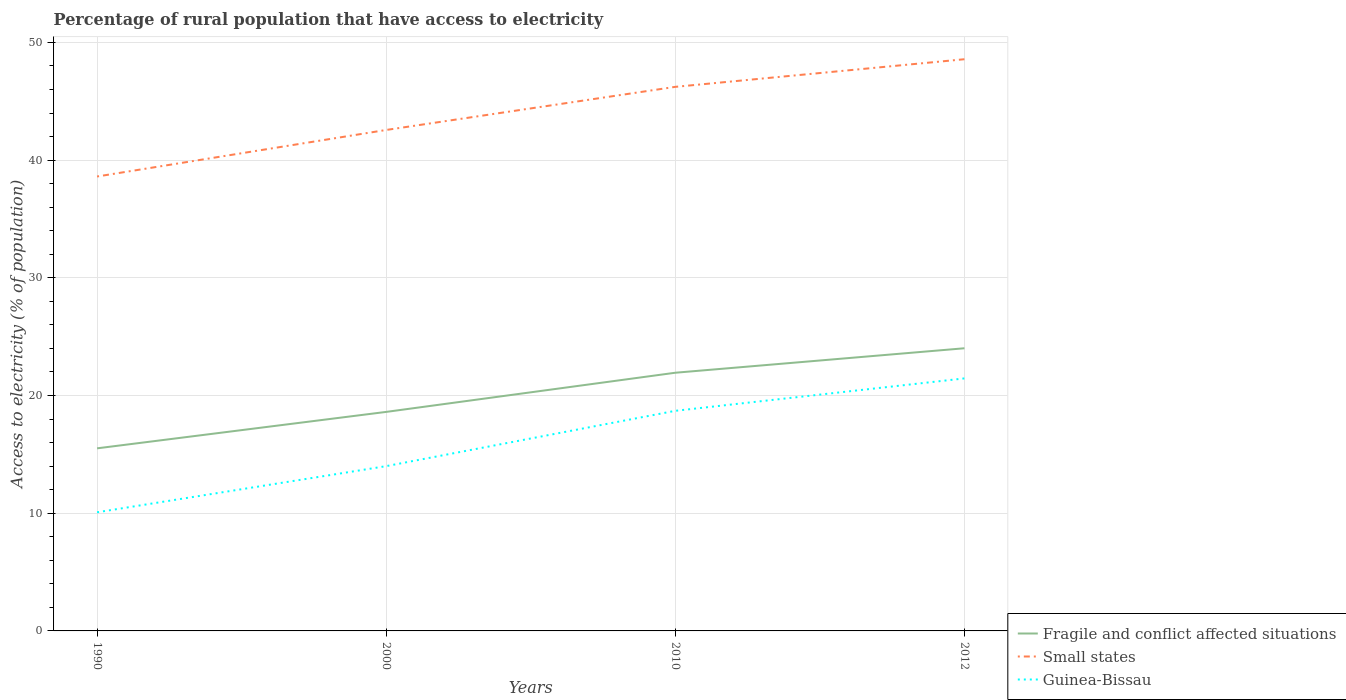How many different coloured lines are there?
Give a very brief answer. 3. Does the line corresponding to Fragile and conflict affected situations intersect with the line corresponding to Small states?
Offer a very short reply. No. Across all years, what is the maximum percentage of rural population that have access to electricity in Fragile and conflict affected situations?
Offer a very short reply. 15.51. In which year was the percentage of rural population that have access to electricity in Guinea-Bissau maximum?
Your response must be concise. 1990. What is the total percentage of rural population that have access to electricity in Small states in the graph?
Your response must be concise. -3.66. What is the difference between the highest and the second highest percentage of rural population that have access to electricity in Fragile and conflict affected situations?
Your response must be concise. 8.5. What is the difference between the highest and the lowest percentage of rural population that have access to electricity in Fragile and conflict affected situations?
Your answer should be compact. 2. How many years are there in the graph?
Ensure brevity in your answer.  4. What is the difference between two consecutive major ticks on the Y-axis?
Your answer should be compact. 10. Does the graph contain grids?
Your answer should be very brief. Yes. Where does the legend appear in the graph?
Provide a succinct answer. Bottom right. How many legend labels are there?
Offer a very short reply. 3. How are the legend labels stacked?
Provide a succinct answer. Vertical. What is the title of the graph?
Keep it short and to the point. Percentage of rural population that have access to electricity. What is the label or title of the X-axis?
Provide a succinct answer. Years. What is the label or title of the Y-axis?
Provide a succinct answer. Access to electricity (% of population). What is the Access to electricity (% of population) of Fragile and conflict affected situations in 1990?
Provide a succinct answer. 15.51. What is the Access to electricity (% of population) in Small states in 1990?
Offer a terse response. 38.61. What is the Access to electricity (% of population) in Guinea-Bissau in 1990?
Your answer should be very brief. 10.08. What is the Access to electricity (% of population) of Fragile and conflict affected situations in 2000?
Offer a terse response. 18.61. What is the Access to electricity (% of population) in Small states in 2000?
Offer a terse response. 42.56. What is the Access to electricity (% of population) of Guinea-Bissau in 2000?
Keep it short and to the point. 14. What is the Access to electricity (% of population) of Fragile and conflict affected situations in 2010?
Provide a short and direct response. 21.94. What is the Access to electricity (% of population) in Small states in 2010?
Ensure brevity in your answer.  46.22. What is the Access to electricity (% of population) of Guinea-Bissau in 2010?
Provide a succinct answer. 18.7. What is the Access to electricity (% of population) of Fragile and conflict affected situations in 2012?
Provide a succinct answer. 24.01. What is the Access to electricity (% of population) of Small states in 2012?
Offer a terse response. 48.57. What is the Access to electricity (% of population) in Guinea-Bissau in 2012?
Ensure brevity in your answer.  21.45. Across all years, what is the maximum Access to electricity (% of population) of Fragile and conflict affected situations?
Make the answer very short. 24.01. Across all years, what is the maximum Access to electricity (% of population) in Small states?
Provide a short and direct response. 48.57. Across all years, what is the maximum Access to electricity (% of population) in Guinea-Bissau?
Your answer should be compact. 21.45. Across all years, what is the minimum Access to electricity (% of population) in Fragile and conflict affected situations?
Your answer should be very brief. 15.51. Across all years, what is the minimum Access to electricity (% of population) in Small states?
Give a very brief answer. 38.61. Across all years, what is the minimum Access to electricity (% of population) in Guinea-Bissau?
Offer a terse response. 10.08. What is the total Access to electricity (% of population) in Fragile and conflict affected situations in the graph?
Ensure brevity in your answer.  80.07. What is the total Access to electricity (% of population) in Small states in the graph?
Provide a succinct answer. 175.96. What is the total Access to electricity (% of population) in Guinea-Bissau in the graph?
Your answer should be compact. 64.23. What is the difference between the Access to electricity (% of population) in Fragile and conflict affected situations in 1990 and that in 2000?
Keep it short and to the point. -3.1. What is the difference between the Access to electricity (% of population) of Small states in 1990 and that in 2000?
Give a very brief answer. -3.95. What is the difference between the Access to electricity (% of population) in Guinea-Bissau in 1990 and that in 2000?
Keep it short and to the point. -3.92. What is the difference between the Access to electricity (% of population) of Fragile and conflict affected situations in 1990 and that in 2010?
Provide a short and direct response. -6.42. What is the difference between the Access to electricity (% of population) in Small states in 1990 and that in 2010?
Your answer should be very brief. -7.62. What is the difference between the Access to electricity (% of population) in Guinea-Bissau in 1990 and that in 2010?
Provide a short and direct response. -8.62. What is the difference between the Access to electricity (% of population) of Fragile and conflict affected situations in 1990 and that in 2012?
Your answer should be very brief. -8.5. What is the difference between the Access to electricity (% of population) in Small states in 1990 and that in 2012?
Ensure brevity in your answer.  -9.96. What is the difference between the Access to electricity (% of population) of Guinea-Bissau in 1990 and that in 2012?
Keep it short and to the point. -11.38. What is the difference between the Access to electricity (% of population) in Fragile and conflict affected situations in 2000 and that in 2010?
Keep it short and to the point. -3.33. What is the difference between the Access to electricity (% of population) in Small states in 2000 and that in 2010?
Keep it short and to the point. -3.66. What is the difference between the Access to electricity (% of population) of Fragile and conflict affected situations in 2000 and that in 2012?
Keep it short and to the point. -5.41. What is the difference between the Access to electricity (% of population) in Small states in 2000 and that in 2012?
Give a very brief answer. -6.01. What is the difference between the Access to electricity (% of population) of Guinea-Bissau in 2000 and that in 2012?
Your answer should be compact. -7.45. What is the difference between the Access to electricity (% of population) of Fragile and conflict affected situations in 2010 and that in 2012?
Make the answer very short. -2.08. What is the difference between the Access to electricity (% of population) of Small states in 2010 and that in 2012?
Keep it short and to the point. -2.35. What is the difference between the Access to electricity (% of population) of Guinea-Bissau in 2010 and that in 2012?
Your answer should be very brief. -2.75. What is the difference between the Access to electricity (% of population) in Fragile and conflict affected situations in 1990 and the Access to electricity (% of population) in Small states in 2000?
Offer a terse response. -27.05. What is the difference between the Access to electricity (% of population) in Fragile and conflict affected situations in 1990 and the Access to electricity (% of population) in Guinea-Bissau in 2000?
Your answer should be compact. 1.51. What is the difference between the Access to electricity (% of population) of Small states in 1990 and the Access to electricity (% of population) of Guinea-Bissau in 2000?
Your answer should be very brief. 24.61. What is the difference between the Access to electricity (% of population) in Fragile and conflict affected situations in 1990 and the Access to electricity (% of population) in Small states in 2010?
Provide a short and direct response. -30.71. What is the difference between the Access to electricity (% of population) in Fragile and conflict affected situations in 1990 and the Access to electricity (% of population) in Guinea-Bissau in 2010?
Your response must be concise. -3.19. What is the difference between the Access to electricity (% of population) in Small states in 1990 and the Access to electricity (% of population) in Guinea-Bissau in 2010?
Provide a short and direct response. 19.91. What is the difference between the Access to electricity (% of population) of Fragile and conflict affected situations in 1990 and the Access to electricity (% of population) of Small states in 2012?
Ensure brevity in your answer.  -33.06. What is the difference between the Access to electricity (% of population) in Fragile and conflict affected situations in 1990 and the Access to electricity (% of population) in Guinea-Bissau in 2012?
Your response must be concise. -5.94. What is the difference between the Access to electricity (% of population) in Small states in 1990 and the Access to electricity (% of population) in Guinea-Bissau in 2012?
Provide a short and direct response. 17.15. What is the difference between the Access to electricity (% of population) in Fragile and conflict affected situations in 2000 and the Access to electricity (% of population) in Small states in 2010?
Make the answer very short. -27.62. What is the difference between the Access to electricity (% of population) of Fragile and conflict affected situations in 2000 and the Access to electricity (% of population) of Guinea-Bissau in 2010?
Provide a succinct answer. -0.09. What is the difference between the Access to electricity (% of population) in Small states in 2000 and the Access to electricity (% of population) in Guinea-Bissau in 2010?
Keep it short and to the point. 23.86. What is the difference between the Access to electricity (% of population) of Fragile and conflict affected situations in 2000 and the Access to electricity (% of population) of Small states in 2012?
Your answer should be very brief. -29.96. What is the difference between the Access to electricity (% of population) in Fragile and conflict affected situations in 2000 and the Access to electricity (% of population) in Guinea-Bissau in 2012?
Provide a short and direct response. -2.85. What is the difference between the Access to electricity (% of population) of Small states in 2000 and the Access to electricity (% of population) of Guinea-Bissau in 2012?
Your response must be concise. 21.11. What is the difference between the Access to electricity (% of population) in Fragile and conflict affected situations in 2010 and the Access to electricity (% of population) in Small states in 2012?
Ensure brevity in your answer.  -26.64. What is the difference between the Access to electricity (% of population) in Fragile and conflict affected situations in 2010 and the Access to electricity (% of population) in Guinea-Bissau in 2012?
Provide a short and direct response. 0.48. What is the difference between the Access to electricity (% of population) of Small states in 2010 and the Access to electricity (% of population) of Guinea-Bissau in 2012?
Ensure brevity in your answer.  24.77. What is the average Access to electricity (% of population) in Fragile and conflict affected situations per year?
Provide a short and direct response. 20.02. What is the average Access to electricity (% of population) of Small states per year?
Offer a very short reply. 43.99. What is the average Access to electricity (% of population) in Guinea-Bissau per year?
Your answer should be compact. 16.06. In the year 1990, what is the difference between the Access to electricity (% of population) in Fragile and conflict affected situations and Access to electricity (% of population) in Small states?
Offer a very short reply. -23.1. In the year 1990, what is the difference between the Access to electricity (% of population) of Fragile and conflict affected situations and Access to electricity (% of population) of Guinea-Bissau?
Provide a short and direct response. 5.43. In the year 1990, what is the difference between the Access to electricity (% of population) in Small states and Access to electricity (% of population) in Guinea-Bissau?
Keep it short and to the point. 28.53. In the year 2000, what is the difference between the Access to electricity (% of population) of Fragile and conflict affected situations and Access to electricity (% of population) of Small states?
Your answer should be very brief. -23.95. In the year 2000, what is the difference between the Access to electricity (% of population) of Fragile and conflict affected situations and Access to electricity (% of population) of Guinea-Bissau?
Offer a terse response. 4.61. In the year 2000, what is the difference between the Access to electricity (% of population) of Small states and Access to electricity (% of population) of Guinea-Bissau?
Provide a short and direct response. 28.56. In the year 2010, what is the difference between the Access to electricity (% of population) of Fragile and conflict affected situations and Access to electricity (% of population) of Small states?
Ensure brevity in your answer.  -24.29. In the year 2010, what is the difference between the Access to electricity (% of population) of Fragile and conflict affected situations and Access to electricity (% of population) of Guinea-Bissau?
Provide a succinct answer. 3.24. In the year 2010, what is the difference between the Access to electricity (% of population) in Small states and Access to electricity (% of population) in Guinea-Bissau?
Offer a very short reply. 27.52. In the year 2012, what is the difference between the Access to electricity (% of population) of Fragile and conflict affected situations and Access to electricity (% of population) of Small states?
Give a very brief answer. -24.56. In the year 2012, what is the difference between the Access to electricity (% of population) in Fragile and conflict affected situations and Access to electricity (% of population) in Guinea-Bissau?
Provide a succinct answer. 2.56. In the year 2012, what is the difference between the Access to electricity (% of population) of Small states and Access to electricity (% of population) of Guinea-Bissau?
Make the answer very short. 27.12. What is the ratio of the Access to electricity (% of population) in Fragile and conflict affected situations in 1990 to that in 2000?
Your answer should be very brief. 0.83. What is the ratio of the Access to electricity (% of population) of Small states in 1990 to that in 2000?
Provide a short and direct response. 0.91. What is the ratio of the Access to electricity (% of population) of Guinea-Bissau in 1990 to that in 2000?
Make the answer very short. 0.72. What is the ratio of the Access to electricity (% of population) of Fragile and conflict affected situations in 1990 to that in 2010?
Provide a succinct answer. 0.71. What is the ratio of the Access to electricity (% of population) of Small states in 1990 to that in 2010?
Your response must be concise. 0.84. What is the ratio of the Access to electricity (% of population) of Guinea-Bissau in 1990 to that in 2010?
Provide a succinct answer. 0.54. What is the ratio of the Access to electricity (% of population) of Fragile and conflict affected situations in 1990 to that in 2012?
Make the answer very short. 0.65. What is the ratio of the Access to electricity (% of population) in Small states in 1990 to that in 2012?
Your answer should be compact. 0.79. What is the ratio of the Access to electricity (% of population) of Guinea-Bissau in 1990 to that in 2012?
Provide a short and direct response. 0.47. What is the ratio of the Access to electricity (% of population) in Fragile and conflict affected situations in 2000 to that in 2010?
Give a very brief answer. 0.85. What is the ratio of the Access to electricity (% of population) of Small states in 2000 to that in 2010?
Offer a terse response. 0.92. What is the ratio of the Access to electricity (% of population) in Guinea-Bissau in 2000 to that in 2010?
Your answer should be compact. 0.75. What is the ratio of the Access to electricity (% of population) of Fragile and conflict affected situations in 2000 to that in 2012?
Provide a short and direct response. 0.77. What is the ratio of the Access to electricity (% of population) in Small states in 2000 to that in 2012?
Provide a succinct answer. 0.88. What is the ratio of the Access to electricity (% of population) of Guinea-Bissau in 2000 to that in 2012?
Your answer should be compact. 0.65. What is the ratio of the Access to electricity (% of population) in Fragile and conflict affected situations in 2010 to that in 2012?
Provide a short and direct response. 0.91. What is the ratio of the Access to electricity (% of population) in Small states in 2010 to that in 2012?
Offer a terse response. 0.95. What is the ratio of the Access to electricity (% of population) in Guinea-Bissau in 2010 to that in 2012?
Provide a short and direct response. 0.87. What is the difference between the highest and the second highest Access to electricity (% of population) in Fragile and conflict affected situations?
Keep it short and to the point. 2.08. What is the difference between the highest and the second highest Access to electricity (% of population) of Small states?
Give a very brief answer. 2.35. What is the difference between the highest and the second highest Access to electricity (% of population) of Guinea-Bissau?
Make the answer very short. 2.75. What is the difference between the highest and the lowest Access to electricity (% of population) of Fragile and conflict affected situations?
Your answer should be compact. 8.5. What is the difference between the highest and the lowest Access to electricity (% of population) in Small states?
Ensure brevity in your answer.  9.96. What is the difference between the highest and the lowest Access to electricity (% of population) of Guinea-Bissau?
Keep it short and to the point. 11.38. 